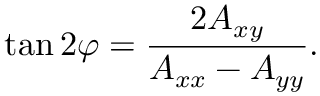Convert formula to latex. <formula><loc_0><loc_0><loc_500><loc_500>\tan 2 \varphi = { \frac { 2 A _ { x y } } { A _ { x x } - A _ { y y } } } .</formula> 